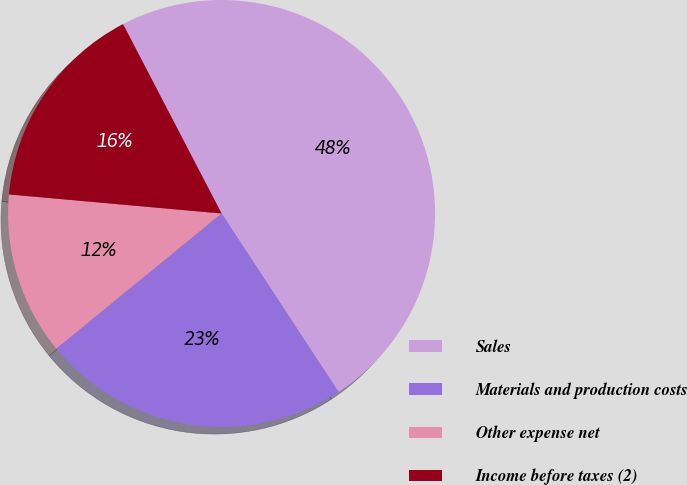<chart> <loc_0><loc_0><loc_500><loc_500><pie_chart><fcel>Sales<fcel>Materials and production costs<fcel>Other expense net<fcel>Income before taxes (2)<nl><fcel>48.4%<fcel>23.32%<fcel>12.33%<fcel>15.94%<nl></chart> 